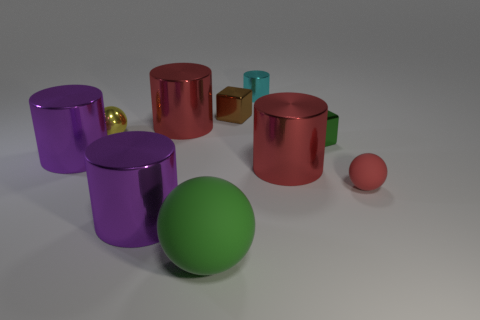Can you tell me more about the surface the objects are resting on? The objects are placed on a matte surface with a slightly bumpy texture. The lack of reflection indicates it might be a type of plastic or painted wood. Do the objects seem to be arranged in a particular pattern or order? While there is no obvious pattern to their arrangement, the objects are spaced apart evenly, which suggests a deliberate placement, possibly for display or as part of a composition. 